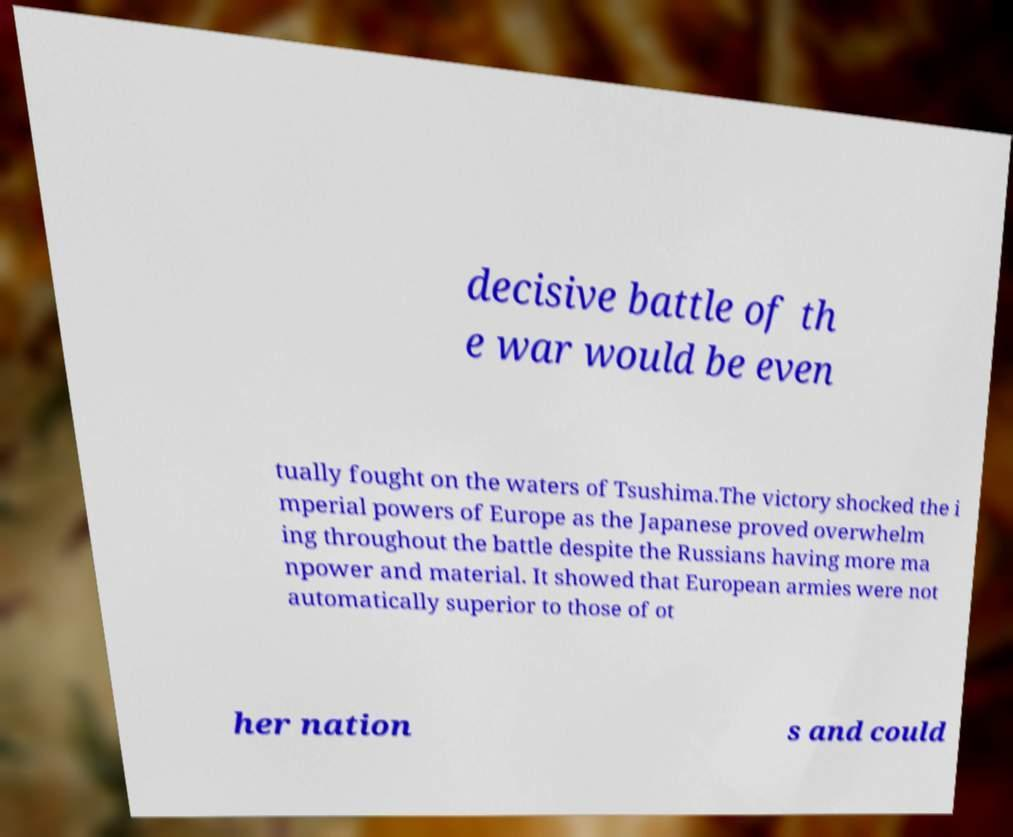Can you accurately transcribe the text from the provided image for me? decisive battle of th e war would be even tually fought on the waters of Tsushima.The victory shocked the i mperial powers of Europe as the Japanese proved overwhelm ing throughout the battle despite the Russians having more ma npower and material. It showed that European armies were not automatically superior to those of ot her nation s and could 